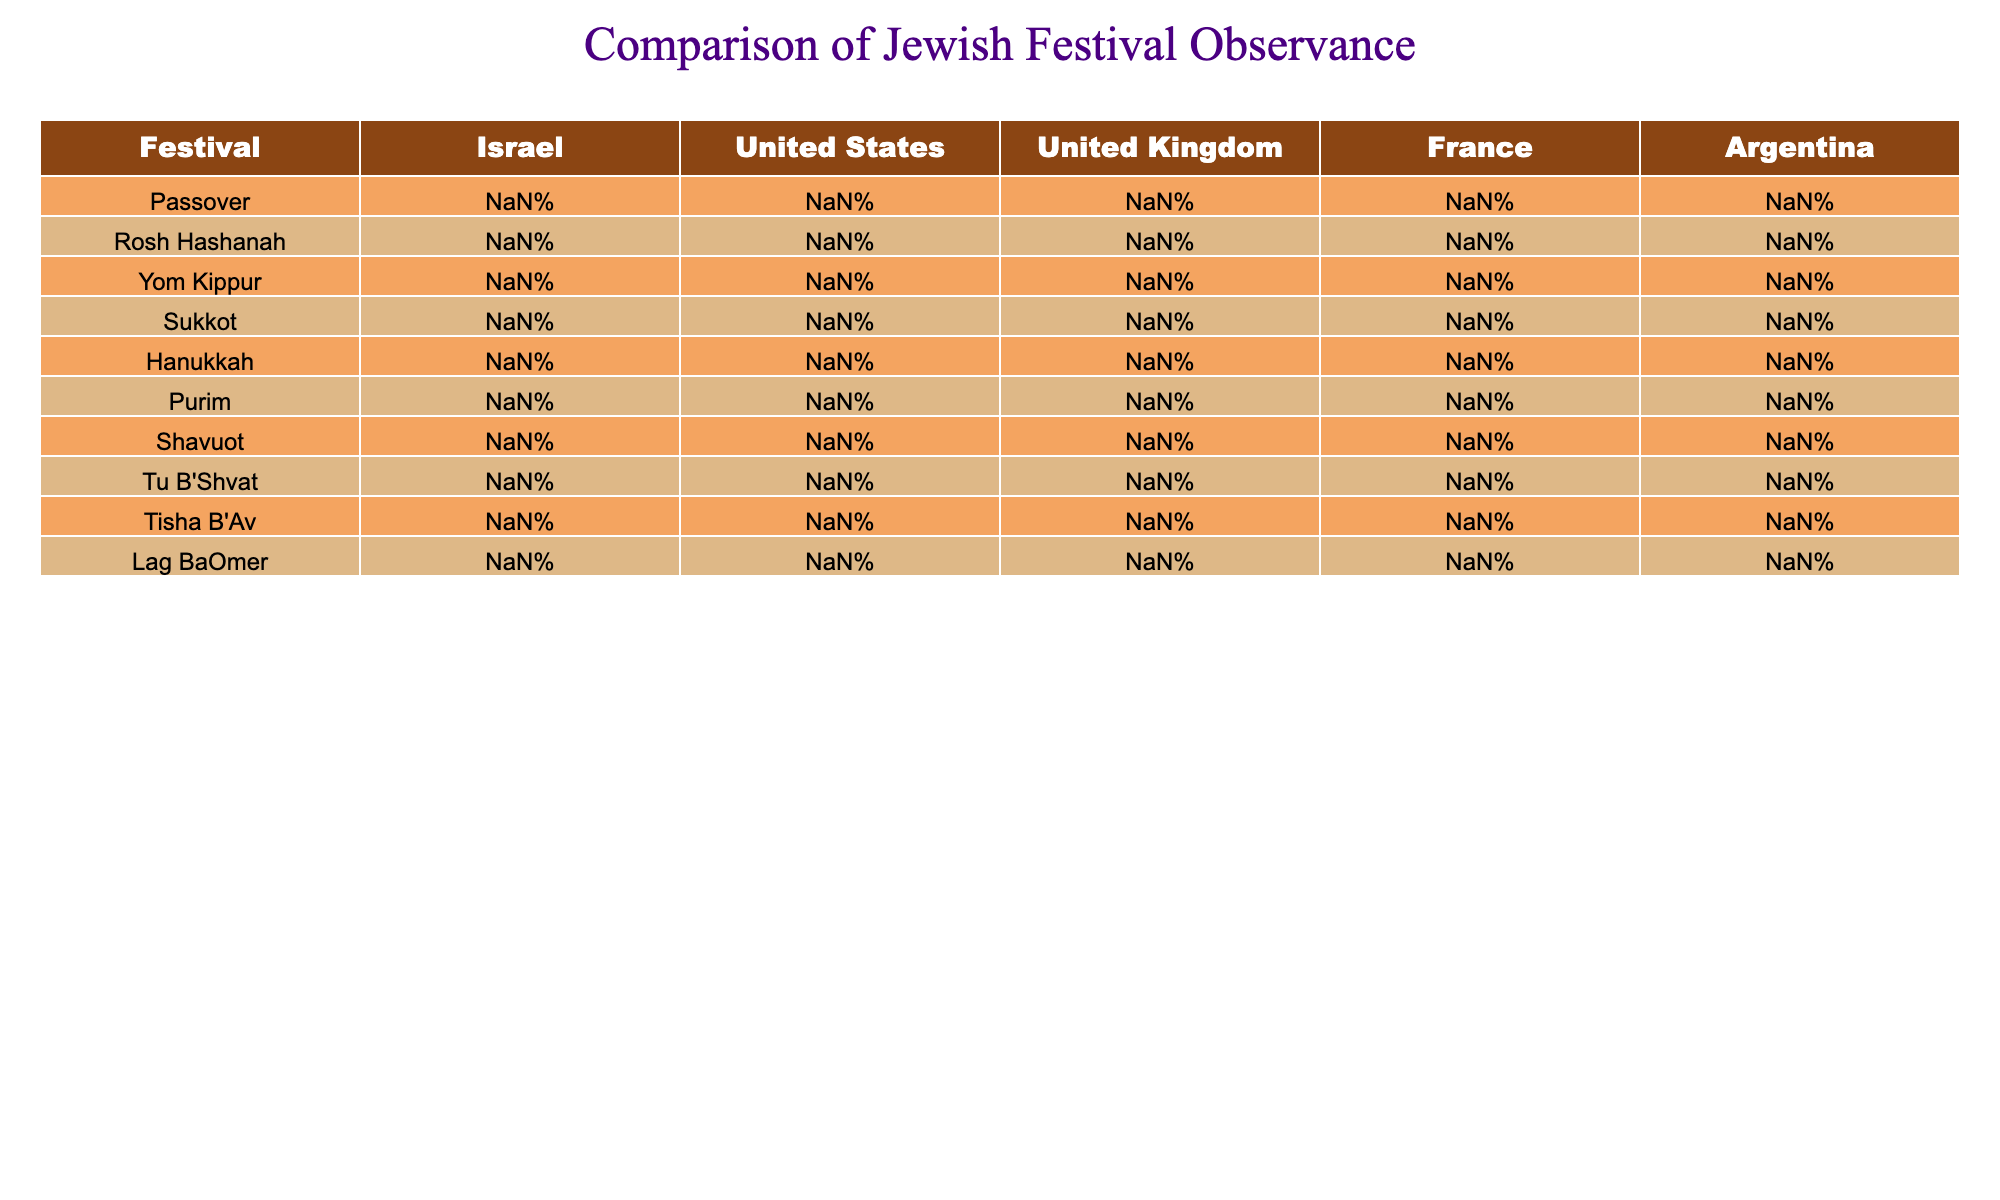What's the highest observance percentage for Yom Kippur in a region? By examining the table, Israel has the highest observance of Yom Kippur at 99%.
Answer: 99% Which festival has the lowest observance in the United States? In the United States, Sukkot has the lowest observance at 40%.
Answer: 40% What is the average observance percentage for Hanukkah across all listed regions? To find the average, add up the percentages for Hanukkah (90% + 80% + 75% + 70% + 85%) which equals 400%, and then divide by 5 regions, resulting in an average of 80%.
Answer: 80% Is Purim observed more than Tu B'Shvat in France? Purim has an observance of 50% in France, while Tu B'Shvat has a lower observance of 20%. Therefore, the answer is yes, Purim is observed more.
Answer: Yes What is the difference in observance percentages between Tisha B'Av and Lag BaOmer in Argentina? Tisha B'Av is observed at 30%, and Lag BaOmer at 25% in Argentina. The difference is 30% - 25% = 5%.
Answer: 5% In which region is Sukkot least observed, and what is the percentage? By inspecting the table, Sukkot has the lowest observance in the United Kingdom at 35%.
Answer: 35% If we combine the observance percentages for Rosh Hashanah in Israel and the United States, what is the total? The observance in Israel is 98%, and in the United States, it is 85%. Adding these gives 98% + 85% = 183%.
Answer: 183% Is the observance of Shavuot higher in the United States than in France? The observance for Shavuot is 35% in the United States and 25% in France; therefore, yes, it is higher in the United States.
Answer: Yes Which festival shows a consistent decline in observance from Israel to the United Kingdom? The table shows a decline for both Sukkot and Shavuot. For Sukkot, it goes from 80% in Israel to 35% in the UK, and for Shavuot, from 75% to 30%.
Answer: Sukkot and Shavuot What is the highest percentage observed for any festival across all regions? The highest percentage observed is for Yom Kippur in Israel at 99%.
Answer: 99% 